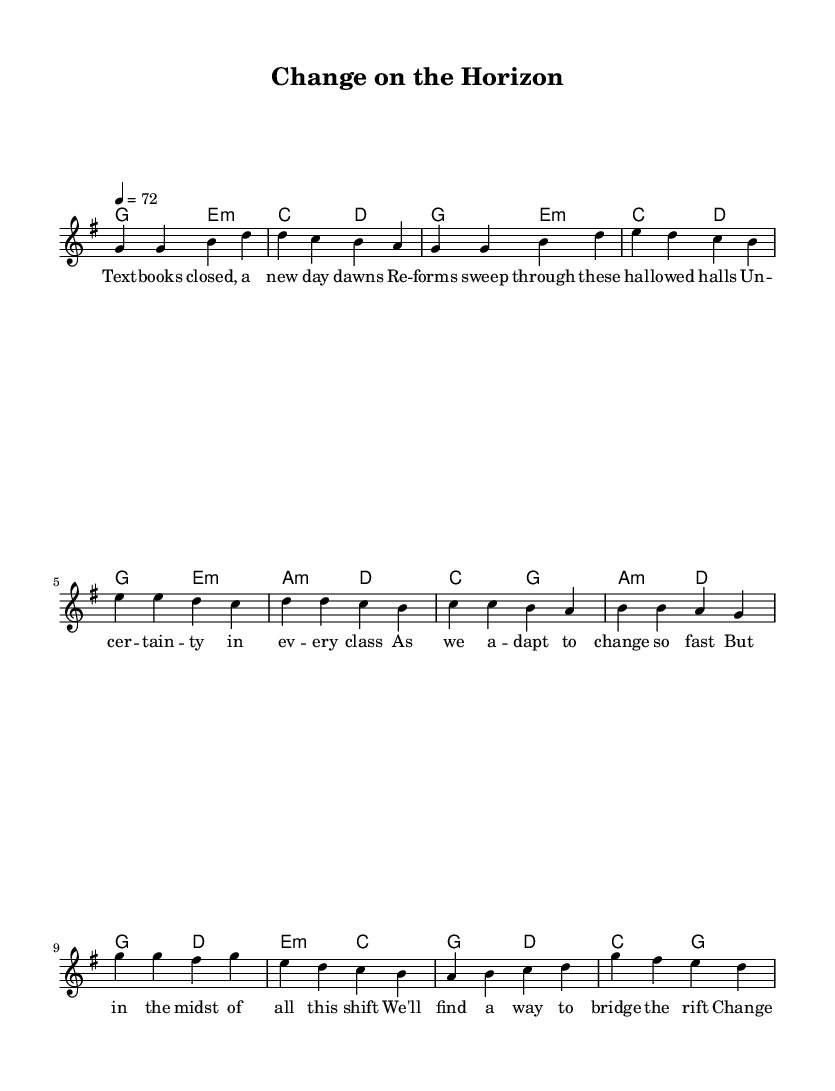What is the key signature of this music? The key signature indicated in the piece is G major, which has one sharp (F#). You can identify the key signature by looking at the beginning of the staff where the sharps and flats are listed.
Answer: G major What is the time signature of the piece? The time signature shown in the score is 4/4, which means there are four beats in each measure and the quarter note gets one beat. This is usually found at the beginning of the staff next to the key signature.
Answer: 4/4 What is the tempo marking for this piece? The tempo is marked as 72 beats per minute, which indicates the speed at which the music should be played. Tempo markings are usually indicated above the staff.
Answer: 72 How many measures are there in the verse? There are four measures in the verse section, which can be counted by looking at the bars indicated by the vertical lines on the staff. The verse consists of eight bars total, but since the prompt asks for the verse specifically, we only consider the initial four.
Answer: 4 Which section of the song is labelled as the chorus? The chorus is indicated as a separate section in the score following the pre-chorus, generally marked clearly in the lyrics and meant to be more prominent in the song structure. The music notes following the pre-chorus signify the start of the chorus.
Answer: Chorus How many different chord types are used in the harmonies section? In the harmonies section, there are four different chord types as suggested by the chord names presented. These include major and minor chords, which can be identified in the chord mode where each chord name is listed over the measures.
Answer: 4 